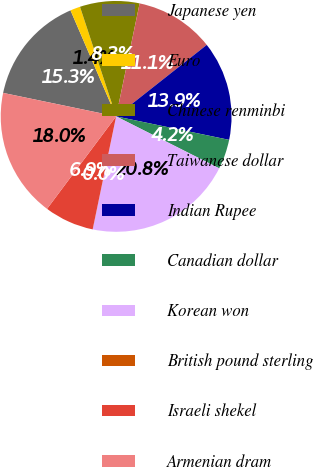Convert chart. <chart><loc_0><loc_0><loc_500><loc_500><pie_chart><fcel>Japanese yen<fcel>Euro<fcel>Chinese renminbi<fcel>Taiwanese dollar<fcel>Indian Rupee<fcel>Canadian dollar<fcel>Korean won<fcel>British pound sterling<fcel>Israeli shekel<fcel>Armenian dram<nl><fcel>15.27%<fcel>1.4%<fcel>8.33%<fcel>11.11%<fcel>13.89%<fcel>4.17%<fcel>20.82%<fcel>0.01%<fcel>6.95%<fcel>18.05%<nl></chart> 